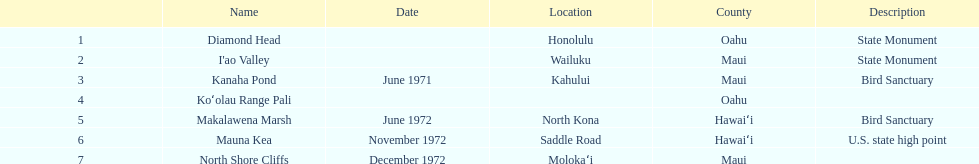How many names do not have a description? 2. 